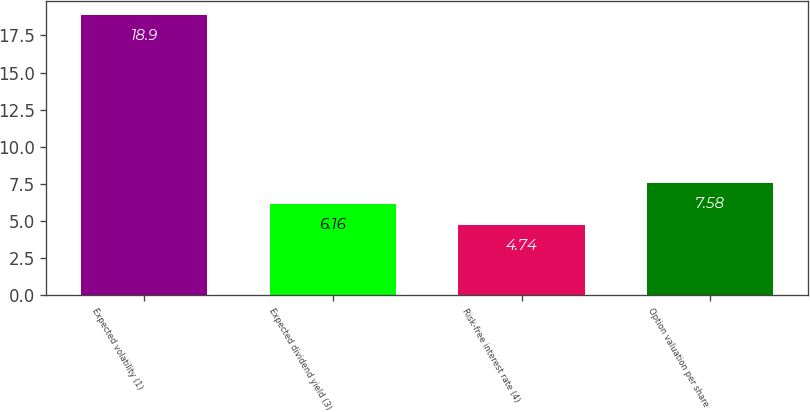Convert chart. <chart><loc_0><loc_0><loc_500><loc_500><bar_chart><fcel>Expected volatility (1)<fcel>Expected dividend yield (3)<fcel>Risk-free interest rate (4)<fcel>Option valuation per share<nl><fcel>18.9<fcel>6.16<fcel>4.74<fcel>7.58<nl></chart> 